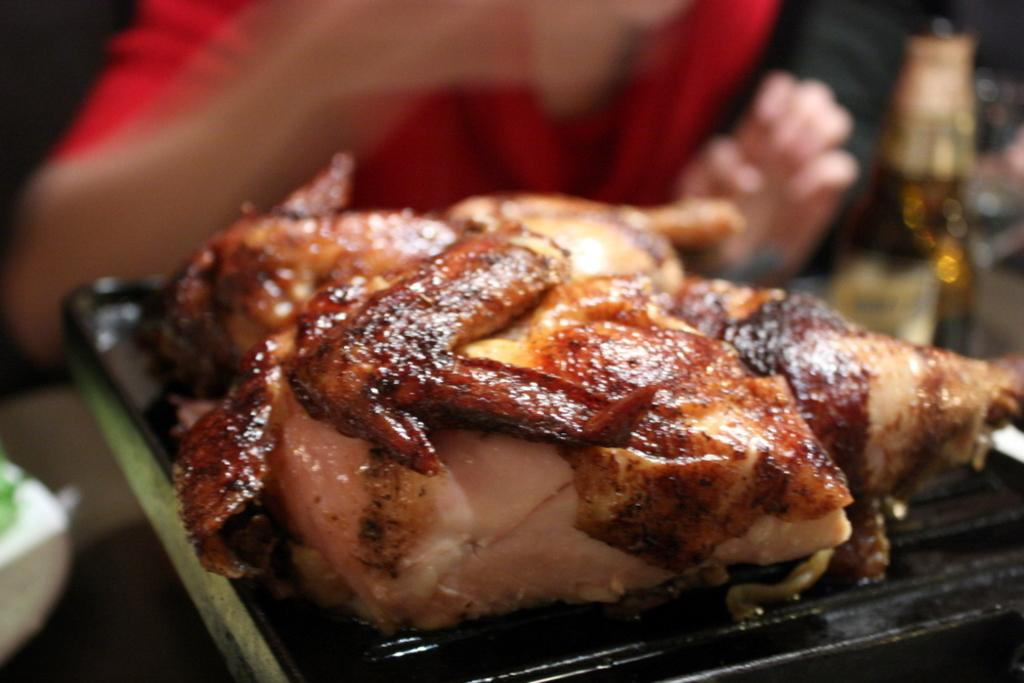What is the main subject in the center of the image? There is a chicken in the center of the image. What is the chicken placed on? The chicken is on a grill. What other object can be seen in the image? There is a bottle in the image. Where is the man located in the image? The man is at the top side of the image. What type of sofa can be seen in the image? There is no sofa present in the image. How many oranges are visible on the grill with the chicken? There are no oranges visible in the image; only the chicken is on the grill. 